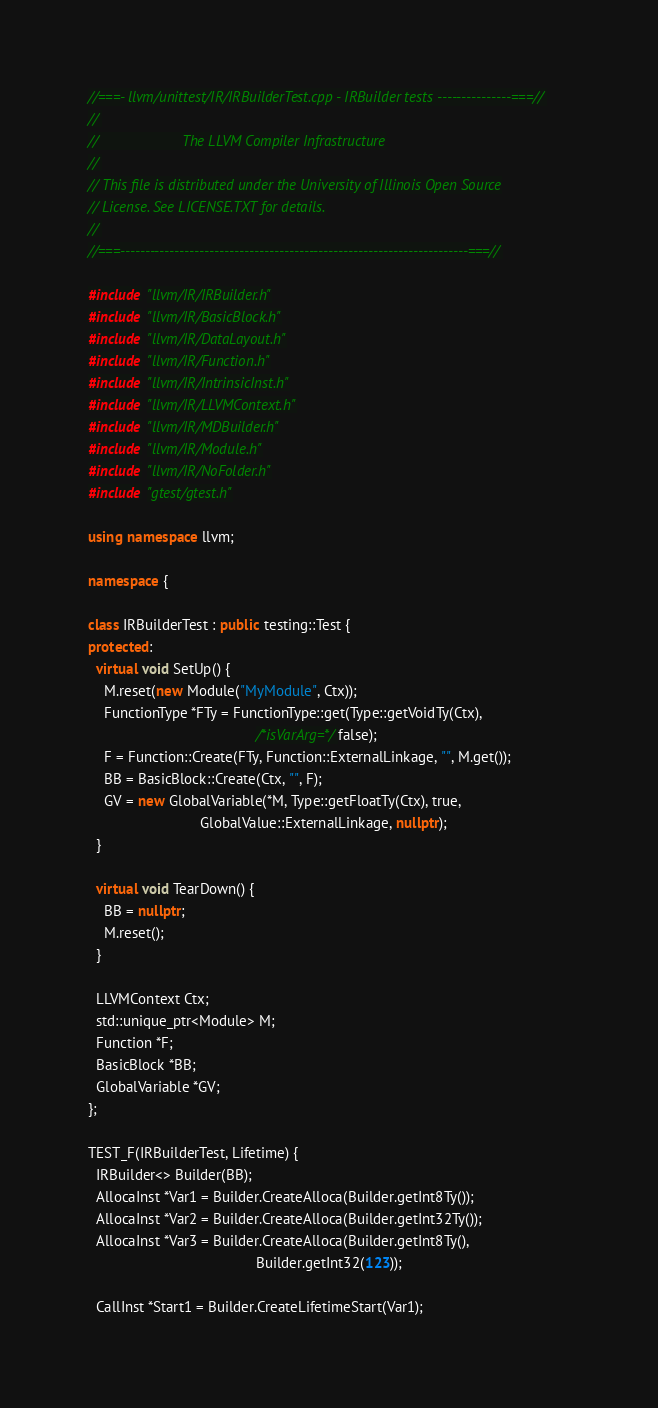Convert code to text. <code><loc_0><loc_0><loc_500><loc_500><_C++_>//===- llvm/unittest/IR/IRBuilderTest.cpp - IRBuilder tests ---------------===//
//
//                     The LLVM Compiler Infrastructure
//
// This file is distributed under the University of Illinois Open Source
// License. See LICENSE.TXT for details.
//
//===----------------------------------------------------------------------===//

#include "llvm/IR/IRBuilder.h"
#include "llvm/IR/BasicBlock.h"
#include "llvm/IR/DataLayout.h"
#include "llvm/IR/Function.h"
#include "llvm/IR/IntrinsicInst.h"
#include "llvm/IR/LLVMContext.h"
#include "llvm/IR/MDBuilder.h"
#include "llvm/IR/Module.h"
#include "llvm/IR/NoFolder.h"
#include "gtest/gtest.h"

using namespace llvm;

namespace {

class IRBuilderTest : public testing::Test {
protected:
  virtual void SetUp() {
    M.reset(new Module("MyModule", Ctx));
    FunctionType *FTy = FunctionType::get(Type::getVoidTy(Ctx),
                                          /*isVarArg=*/false);
    F = Function::Create(FTy, Function::ExternalLinkage, "", M.get());
    BB = BasicBlock::Create(Ctx, "", F);
    GV = new GlobalVariable(*M, Type::getFloatTy(Ctx), true,
                            GlobalValue::ExternalLinkage, nullptr);
  }

  virtual void TearDown() {
    BB = nullptr;
    M.reset();
  }

  LLVMContext Ctx;
  std::unique_ptr<Module> M;
  Function *F;
  BasicBlock *BB;
  GlobalVariable *GV;
};

TEST_F(IRBuilderTest, Lifetime) {
  IRBuilder<> Builder(BB);
  AllocaInst *Var1 = Builder.CreateAlloca(Builder.getInt8Ty());
  AllocaInst *Var2 = Builder.CreateAlloca(Builder.getInt32Ty());
  AllocaInst *Var3 = Builder.CreateAlloca(Builder.getInt8Ty(),
                                          Builder.getInt32(123));

  CallInst *Start1 = Builder.CreateLifetimeStart(Var1);</code> 